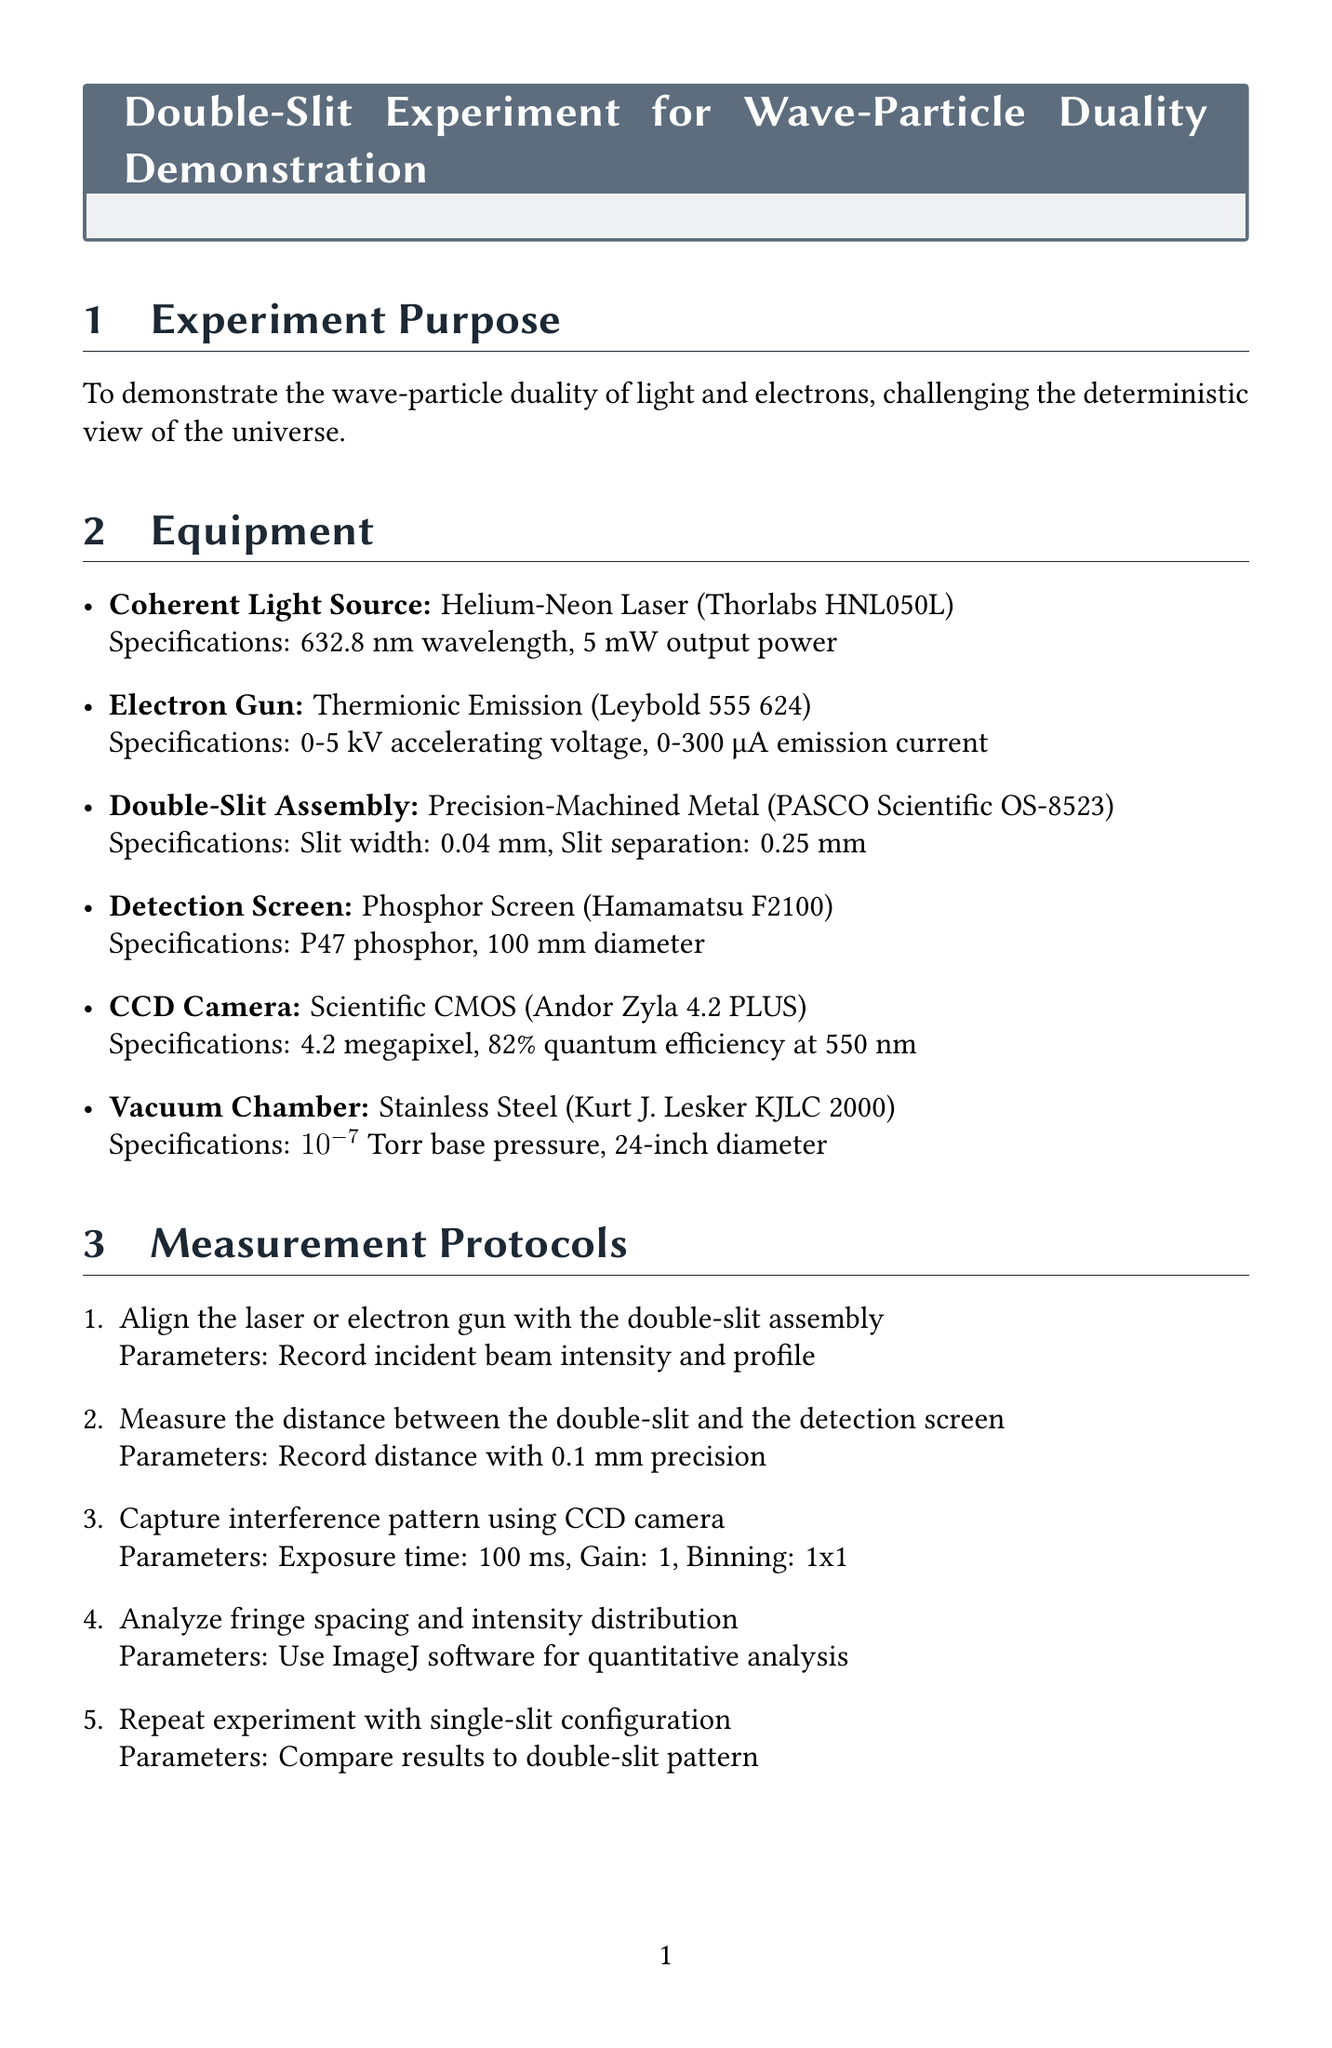what is the wavelength of the laser used? The document states the wavelength of the helium-neon laser is 632.8 nm.
Answer: 632.8 nm what type of electron gun is used in the experiment? The document specifies a thermionic emission type for the electron gun.
Answer: Thermionic Emission what is the slit width in the double-slit assembly? According to the document, the slit width is 0.04 mm.
Answer: 0.04 mm how long is the exposure time for the CCD camera? The document indicates that the exposure time is 100 ms.
Answer: 100 ms what software is used for quantitative analysis of the interference pattern? The document mentions the use of ImageJ software for analysis.
Answer: ImageJ what is the base pressure of the vacuum chamber? The document states the base pressure of the vacuum chamber is 10^-7 Torr.
Answer: 10^-7 Torr which principle challenges deterministic views according to the theoretical considerations? The document refers to Bohr's complementarity principle as a challenge.
Answer: Complementarity Principle what is the maximum emission current of the electron gun? The document describes the maximum emission current of the electron gun as 300 μA.
Answer: 300 μA what are the safety goggles required for the laser? The document specifies the need for goggles with an optical density of 7+ at 633 nm.
Answer: OD 7+ at 633 nm 